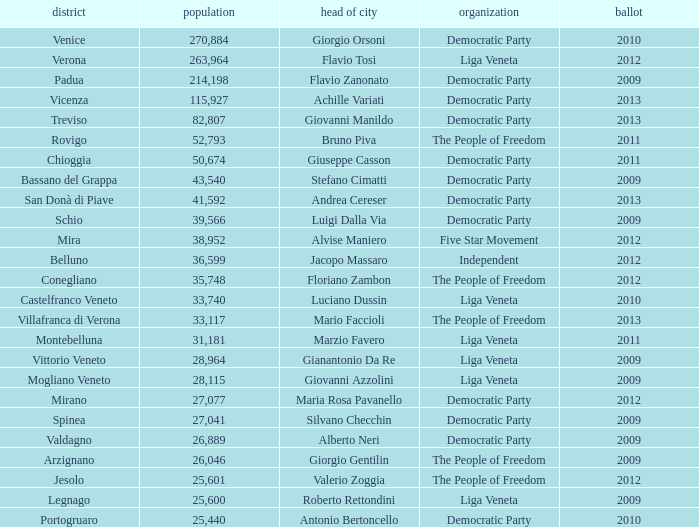How many Inhabitants were in the democratic party for an election before 2009 for Mayor of stefano cimatti? 0.0. 